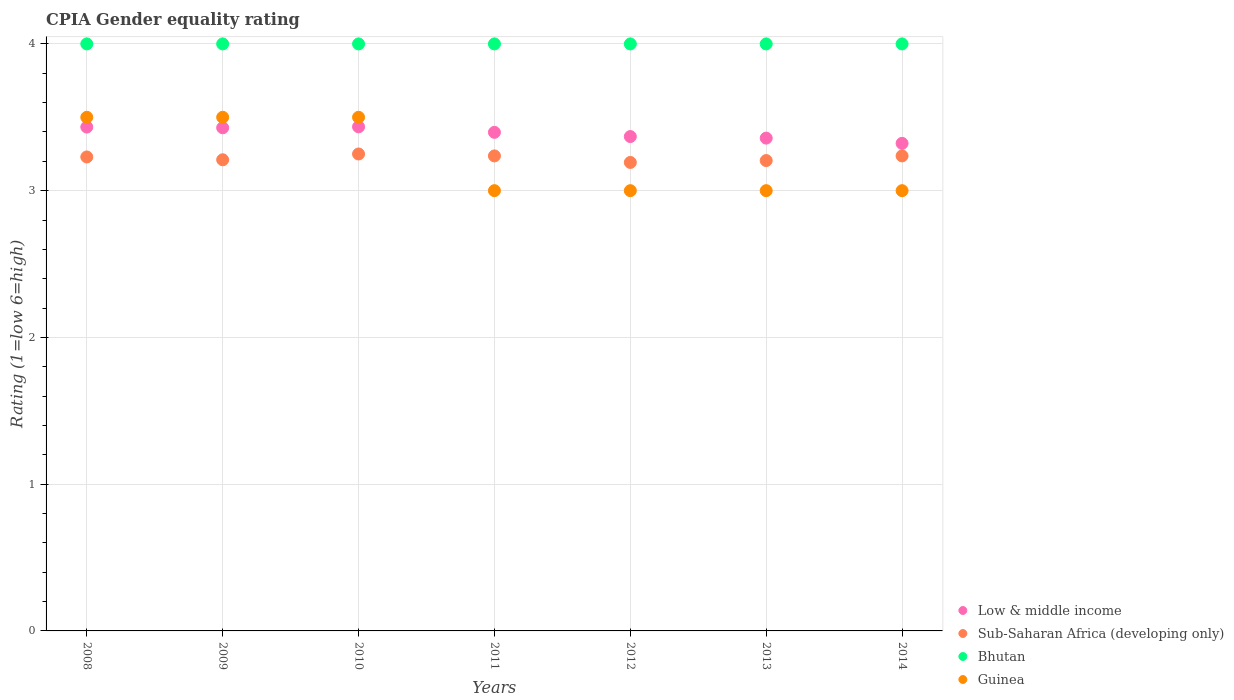Across all years, what is the maximum CPIA rating in Low & middle income?
Your answer should be very brief. 3.44. Across all years, what is the minimum CPIA rating in Guinea?
Offer a very short reply. 3. In which year was the CPIA rating in Guinea minimum?
Ensure brevity in your answer.  2011. What is the difference between the CPIA rating in Sub-Saharan Africa (developing only) in 2014 and the CPIA rating in Low & middle income in 2008?
Your response must be concise. -0.2. What is the average CPIA rating in Guinea per year?
Give a very brief answer. 3.21. In the year 2011, what is the difference between the CPIA rating in Bhutan and CPIA rating in Guinea?
Offer a terse response. 1. What is the ratio of the CPIA rating in Sub-Saharan Africa (developing only) in 2010 to that in 2013?
Keep it short and to the point. 1.01. Is the CPIA rating in Sub-Saharan Africa (developing only) in 2008 less than that in 2012?
Your answer should be compact. No. What is the difference between the highest and the second highest CPIA rating in Guinea?
Your answer should be compact. 0. What is the difference between the highest and the lowest CPIA rating in Sub-Saharan Africa (developing only)?
Provide a short and direct response. 0.06. In how many years, is the CPIA rating in Low & middle income greater than the average CPIA rating in Low & middle income taken over all years?
Provide a succinct answer. 4. Is the sum of the CPIA rating in Guinea in 2008 and 2010 greater than the maximum CPIA rating in Sub-Saharan Africa (developing only) across all years?
Keep it short and to the point. Yes. Is it the case that in every year, the sum of the CPIA rating in Guinea and CPIA rating in Low & middle income  is greater than the sum of CPIA rating in Sub-Saharan Africa (developing only) and CPIA rating in Bhutan?
Provide a succinct answer. No. Is the CPIA rating in Low & middle income strictly greater than the CPIA rating in Guinea over the years?
Your answer should be compact. No. Is the CPIA rating in Low & middle income strictly less than the CPIA rating in Sub-Saharan Africa (developing only) over the years?
Your response must be concise. No. How many dotlines are there?
Your answer should be very brief. 4. Does the graph contain any zero values?
Ensure brevity in your answer.  No. Does the graph contain grids?
Ensure brevity in your answer.  Yes. How are the legend labels stacked?
Offer a very short reply. Vertical. What is the title of the graph?
Offer a very short reply. CPIA Gender equality rating. What is the label or title of the X-axis?
Provide a succinct answer. Years. What is the Rating (1=low 6=high) in Low & middle income in 2008?
Give a very brief answer. 3.43. What is the Rating (1=low 6=high) of Sub-Saharan Africa (developing only) in 2008?
Give a very brief answer. 3.23. What is the Rating (1=low 6=high) in Bhutan in 2008?
Your response must be concise. 4. What is the Rating (1=low 6=high) of Guinea in 2008?
Offer a very short reply. 3.5. What is the Rating (1=low 6=high) of Low & middle income in 2009?
Provide a succinct answer. 3.43. What is the Rating (1=low 6=high) in Sub-Saharan Africa (developing only) in 2009?
Provide a short and direct response. 3.21. What is the Rating (1=low 6=high) of Bhutan in 2009?
Make the answer very short. 4. What is the Rating (1=low 6=high) of Guinea in 2009?
Ensure brevity in your answer.  3.5. What is the Rating (1=low 6=high) in Low & middle income in 2010?
Your answer should be very brief. 3.44. What is the Rating (1=low 6=high) of Sub-Saharan Africa (developing only) in 2010?
Offer a terse response. 3.25. What is the Rating (1=low 6=high) of Bhutan in 2010?
Offer a terse response. 4. What is the Rating (1=low 6=high) in Guinea in 2010?
Your answer should be compact. 3.5. What is the Rating (1=low 6=high) of Low & middle income in 2011?
Your answer should be compact. 3.4. What is the Rating (1=low 6=high) in Sub-Saharan Africa (developing only) in 2011?
Make the answer very short. 3.24. What is the Rating (1=low 6=high) in Bhutan in 2011?
Ensure brevity in your answer.  4. What is the Rating (1=low 6=high) of Guinea in 2011?
Offer a terse response. 3. What is the Rating (1=low 6=high) of Low & middle income in 2012?
Provide a short and direct response. 3.37. What is the Rating (1=low 6=high) in Sub-Saharan Africa (developing only) in 2012?
Keep it short and to the point. 3.19. What is the Rating (1=low 6=high) in Guinea in 2012?
Your answer should be very brief. 3. What is the Rating (1=low 6=high) in Low & middle income in 2013?
Ensure brevity in your answer.  3.36. What is the Rating (1=low 6=high) in Sub-Saharan Africa (developing only) in 2013?
Offer a very short reply. 3.21. What is the Rating (1=low 6=high) in Low & middle income in 2014?
Your answer should be compact. 3.32. What is the Rating (1=low 6=high) in Sub-Saharan Africa (developing only) in 2014?
Provide a succinct answer. 3.24. What is the Rating (1=low 6=high) in Guinea in 2014?
Ensure brevity in your answer.  3. Across all years, what is the maximum Rating (1=low 6=high) in Low & middle income?
Offer a very short reply. 3.44. Across all years, what is the maximum Rating (1=low 6=high) of Sub-Saharan Africa (developing only)?
Make the answer very short. 3.25. Across all years, what is the maximum Rating (1=low 6=high) in Guinea?
Provide a succinct answer. 3.5. Across all years, what is the minimum Rating (1=low 6=high) in Low & middle income?
Provide a succinct answer. 3.32. Across all years, what is the minimum Rating (1=low 6=high) of Sub-Saharan Africa (developing only)?
Give a very brief answer. 3.19. Across all years, what is the minimum Rating (1=low 6=high) in Bhutan?
Offer a very short reply. 4. Across all years, what is the minimum Rating (1=low 6=high) in Guinea?
Your response must be concise. 3. What is the total Rating (1=low 6=high) in Low & middle income in the graph?
Provide a short and direct response. 23.74. What is the total Rating (1=low 6=high) of Sub-Saharan Africa (developing only) in the graph?
Provide a succinct answer. 22.56. What is the total Rating (1=low 6=high) of Bhutan in the graph?
Your answer should be very brief. 28. What is the difference between the Rating (1=low 6=high) of Low & middle income in 2008 and that in 2009?
Keep it short and to the point. 0. What is the difference between the Rating (1=low 6=high) in Sub-Saharan Africa (developing only) in 2008 and that in 2009?
Make the answer very short. 0.02. What is the difference between the Rating (1=low 6=high) of Bhutan in 2008 and that in 2009?
Provide a short and direct response. 0. What is the difference between the Rating (1=low 6=high) in Low & middle income in 2008 and that in 2010?
Make the answer very short. -0. What is the difference between the Rating (1=low 6=high) in Sub-Saharan Africa (developing only) in 2008 and that in 2010?
Provide a short and direct response. -0.02. What is the difference between the Rating (1=low 6=high) of Low & middle income in 2008 and that in 2011?
Your response must be concise. 0.04. What is the difference between the Rating (1=low 6=high) of Sub-Saharan Africa (developing only) in 2008 and that in 2011?
Give a very brief answer. -0.01. What is the difference between the Rating (1=low 6=high) of Low & middle income in 2008 and that in 2012?
Ensure brevity in your answer.  0.06. What is the difference between the Rating (1=low 6=high) in Sub-Saharan Africa (developing only) in 2008 and that in 2012?
Your response must be concise. 0.04. What is the difference between the Rating (1=low 6=high) in Low & middle income in 2008 and that in 2013?
Make the answer very short. 0.08. What is the difference between the Rating (1=low 6=high) of Sub-Saharan Africa (developing only) in 2008 and that in 2013?
Your answer should be very brief. 0.02. What is the difference between the Rating (1=low 6=high) of Low & middle income in 2008 and that in 2014?
Keep it short and to the point. 0.11. What is the difference between the Rating (1=low 6=high) in Sub-Saharan Africa (developing only) in 2008 and that in 2014?
Provide a succinct answer. -0.01. What is the difference between the Rating (1=low 6=high) in Low & middle income in 2009 and that in 2010?
Your answer should be compact. -0.01. What is the difference between the Rating (1=low 6=high) of Sub-Saharan Africa (developing only) in 2009 and that in 2010?
Offer a very short reply. -0.04. What is the difference between the Rating (1=low 6=high) in Bhutan in 2009 and that in 2010?
Provide a succinct answer. 0. What is the difference between the Rating (1=low 6=high) in Guinea in 2009 and that in 2010?
Ensure brevity in your answer.  0. What is the difference between the Rating (1=low 6=high) in Low & middle income in 2009 and that in 2011?
Offer a very short reply. 0.03. What is the difference between the Rating (1=low 6=high) of Sub-Saharan Africa (developing only) in 2009 and that in 2011?
Keep it short and to the point. -0.03. What is the difference between the Rating (1=low 6=high) of Bhutan in 2009 and that in 2011?
Provide a succinct answer. 0. What is the difference between the Rating (1=low 6=high) in Guinea in 2009 and that in 2011?
Your response must be concise. 0.5. What is the difference between the Rating (1=low 6=high) of Low & middle income in 2009 and that in 2012?
Provide a short and direct response. 0.06. What is the difference between the Rating (1=low 6=high) of Sub-Saharan Africa (developing only) in 2009 and that in 2012?
Provide a succinct answer. 0.02. What is the difference between the Rating (1=low 6=high) in Guinea in 2009 and that in 2012?
Provide a succinct answer. 0.5. What is the difference between the Rating (1=low 6=high) in Low & middle income in 2009 and that in 2013?
Make the answer very short. 0.07. What is the difference between the Rating (1=low 6=high) in Sub-Saharan Africa (developing only) in 2009 and that in 2013?
Your answer should be compact. 0.01. What is the difference between the Rating (1=low 6=high) in Bhutan in 2009 and that in 2013?
Provide a succinct answer. 0. What is the difference between the Rating (1=low 6=high) of Guinea in 2009 and that in 2013?
Offer a terse response. 0.5. What is the difference between the Rating (1=low 6=high) of Low & middle income in 2009 and that in 2014?
Provide a succinct answer. 0.11. What is the difference between the Rating (1=low 6=high) in Sub-Saharan Africa (developing only) in 2009 and that in 2014?
Give a very brief answer. -0.03. What is the difference between the Rating (1=low 6=high) in Bhutan in 2009 and that in 2014?
Your response must be concise. 0. What is the difference between the Rating (1=low 6=high) in Low & middle income in 2010 and that in 2011?
Ensure brevity in your answer.  0.04. What is the difference between the Rating (1=low 6=high) of Sub-Saharan Africa (developing only) in 2010 and that in 2011?
Give a very brief answer. 0.01. What is the difference between the Rating (1=low 6=high) of Bhutan in 2010 and that in 2011?
Your answer should be very brief. 0. What is the difference between the Rating (1=low 6=high) of Guinea in 2010 and that in 2011?
Provide a succinct answer. 0.5. What is the difference between the Rating (1=low 6=high) of Low & middle income in 2010 and that in 2012?
Offer a terse response. 0.07. What is the difference between the Rating (1=low 6=high) in Sub-Saharan Africa (developing only) in 2010 and that in 2012?
Offer a terse response. 0.06. What is the difference between the Rating (1=low 6=high) of Low & middle income in 2010 and that in 2013?
Keep it short and to the point. 0.08. What is the difference between the Rating (1=low 6=high) in Sub-Saharan Africa (developing only) in 2010 and that in 2013?
Ensure brevity in your answer.  0.04. What is the difference between the Rating (1=low 6=high) of Low & middle income in 2010 and that in 2014?
Make the answer very short. 0.11. What is the difference between the Rating (1=low 6=high) in Sub-Saharan Africa (developing only) in 2010 and that in 2014?
Your answer should be compact. 0.01. What is the difference between the Rating (1=low 6=high) in Bhutan in 2010 and that in 2014?
Your response must be concise. 0. What is the difference between the Rating (1=low 6=high) in Guinea in 2010 and that in 2014?
Give a very brief answer. 0.5. What is the difference between the Rating (1=low 6=high) of Low & middle income in 2011 and that in 2012?
Provide a succinct answer. 0.03. What is the difference between the Rating (1=low 6=high) of Sub-Saharan Africa (developing only) in 2011 and that in 2012?
Your response must be concise. 0.04. What is the difference between the Rating (1=low 6=high) in Bhutan in 2011 and that in 2012?
Ensure brevity in your answer.  0. What is the difference between the Rating (1=low 6=high) of Guinea in 2011 and that in 2012?
Your answer should be very brief. 0. What is the difference between the Rating (1=low 6=high) in Low & middle income in 2011 and that in 2013?
Provide a short and direct response. 0.04. What is the difference between the Rating (1=low 6=high) in Sub-Saharan Africa (developing only) in 2011 and that in 2013?
Your response must be concise. 0.03. What is the difference between the Rating (1=low 6=high) of Low & middle income in 2011 and that in 2014?
Your response must be concise. 0.08. What is the difference between the Rating (1=low 6=high) of Guinea in 2011 and that in 2014?
Offer a very short reply. 0. What is the difference between the Rating (1=low 6=high) in Low & middle income in 2012 and that in 2013?
Offer a very short reply. 0.01. What is the difference between the Rating (1=low 6=high) of Sub-Saharan Africa (developing only) in 2012 and that in 2013?
Your answer should be very brief. -0.01. What is the difference between the Rating (1=low 6=high) of Bhutan in 2012 and that in 2013?
Offer a very short reply. 0. What is the difference between the Rating (1=low 6=high) of Low & middle income in 2012 and that in 2014?
Your response must be concise. 0.05. What is the difference between the Rating (1=low 6=high) in Sub-Saharan Africa (developing only) in 2012 and that in 2014?
Offer a terse response. -0.04. What is the difference between the Rating (1=low 6=high) of Guinea in 2012 and that in 2014?
Your answer should be very brief. 0. What is the difference between the Rating (1=low 6=high) of Low & middle income in 2013 and that in 2014?
Your response must be concise. 0.04. What is the difference between the Rating (1=low 6=high) of Sub-Saharan Africa (developing only) in 2013 and that in 2014?
Keep it short and to the point. -0.03. What is the difference between the Rating (1=low 6=high) of Guinea in 2013 and that in 2014?
Offer a terse response. 0. What is the difference between the Rating (1=low 6=high) in Low & middle income in 2008 and the Rating (1=low 6=high) in Sub-Saharan Africa (developing only) in 2009?
Give a very brief answer. 0.22. What is the difference between the Rating (1=low 6=high) of Low & middle income in 2008 and the Rating (1=low 6=high) of Bhutan in 2009?
Keep it short and to the point. -0.57. What is the difference between the Rating (1=low 6=high) of Low & middle income in 2008 and the Rating (1=low 6=high) of Guinea in 2009?
Give a very brief answer. -0.07. What is the difference between the Rating (1=low 6=high) of Sub-Saharan Africa (developing only) in 2008 and the Rating (1=low 6=high) of Bhutan in 2009?
Make the answer very short. -0.77. What is the difference between the Rating (1=low 6=high) in Sub-Saharan Africa (developing only) in 2008 and the Rating (1=low 6=high) in Guinea in 2009?
Provide a short and direct response. -0.27. What is the difference between the Rating (1=low 6=high) in Low & middle income in 2008 and the Rating (1=low 6=high) in Sub-Saharan Africa (developing only) in 2010?
Your answer should be very brief. 0.18. What is the difference between the Rating (1=low 6=high) in Low & middle income in 2008 and the Rating (1=low 6=high) in Bhutan in 2010?
Make the answer very short. -0.57. What is the difference between the Rating (1=low 6=high) of Low & middle income in 2008 and the Rating (1=low 6=high) of Guinea in 2010?
Your answer should be very brief. -0.07. What is the difference between the Rating (1=low 6=high) of Sub-Saharan Africa (developing only) in 2008 and the Rating (1=low 6=high) of Bhutan in 2010?
Your answer should be compact. -0.77. What is the difference between the Rating (1=low 6=high) of Sub-Saharan Africa (developing only) in 2008 and the Rating (1=low 6=high) of Guinea in 2010?
Make the answer very short. -0.27. What is the difference between the Rating (1=low 6=high) of Bhutan in 2008 and the Rating (1=low 6=high) of Guinea in 2010?
Ensure brevity in your answer.  0.5. What is the difference between the Rating (1=low 6=high) of Low & middle income in 2008 and the Rating (1=low 6=high) of Sub-Saharan Africa (developing only) in 2011?
Keep it short and to the point. 0.2. What is the difference between the Rating (1=low 6=high) of Low & middle income in 2008 and the Rating (1=low 6=high) of Bhutan in 2011?
Provide a short and direct response. -0.57. What is the difference between the Rating (1=low 6=high) of Low & middle income in 2008 and the Rating (1=low 6=high) of Guinea in 2011?
Your answer should be compact. 0.43. What is the difference between the Rating (1=low 6=high) in Sub-Saharan Africa (developing only) in 2008 and the Rating (1=low 6=high) in Bhutan in 2011?
Your response must be concise. -0.77. What is the difference between the Rating (1=low 6=high) in Sub-Saharan Africa (developing only) in 2008 and the Rating (1=low 6=high) in Guinea in 2011?
Provide a succinct answer. 0.23. What is the difference between the Rating (1=low 6=high) of Low & middle income in 2008 and the Rating (1=low 6=high) of Sub-Saharan Africa (developing only) in 2012?
Provide a short and direct response. 0.24. What is the difference between the Rating (1=low 6=high) of Low & middle income in 2008 and the Rating (1=low 6=high) of Bhutan in 2012?
Make the answer very short. -0.57. What is the difference between the Rating (1=low 6=high) of Low & middle income in 2008 and the Rating (1=low 6=high) of Guinea in 2012?
Your answer should be compact. 0.43. What is the difference between the Rating (1=low 6=high) in Sub-Saharan Africa (developing only) in 2008 and the Rating (1=low 6=high) in Bhutan in 2012?
Your answer should be very brief. -0.77. What is the difference between the Rating (1=low 6=high) in Sub-Saharan Africa (developing only) in 2008 and the Rating (1=low 6=high) in Guinea in 2012?
Your answer should be very brief. 0.23. What is the difference between the Rating (1=low 6=high) in Bhutan in 2008 and the Rating (1=low 6=high) in Guinea in 2012?
Your response must be concise. 1. What is the difference between the Rating (1=low 6=high) in Low & middle income in 2008 and the Rating (1=low 6=high) in Sub-Saharan Africa (developing only) in 2013?
Your answer should be very brief. 0.23. What is the difference between the Rating (1=low 6=high) of Low & middle income in 2008 and the Rating (1=low 6=high) of Bhutan in 2013?
Ensure brevity in your answer.  -0.57. What is the difference between the Rating (1=low 6=high) in Low & middle income in 2008 and the Rating (1=low 6=high) in Guinea in 2013?
Make the answer very short. 0.43. What is the difference between the Rating (1=low 6=high) in Sub-Saharan Africa (developing only) in 2008 and the Rating (1=low 6=high) in Bhutan in 2013?
Your answer should be very brief. -0.77. What is the difference between the Rating (1=low 6=high) of Sub-Saharan Africa (developing only) in 2008 and the Rating (1=low 6=high) of Guinea in 2013?
Provide a short and direct response. 0.23. What is the difference between the Rating (1=low 6=high) in Low & middle income in 2008 and the Rating (1=low 6=high) in Sub-Saharan Africa (developing only) in 2014?
Give a very brief answer. 0.2. What is the difference between the Rating (1=low 6=high) of Low & middle income in 2008 and the Rating (1=low 6=high) of Bhutan in 2014?
Offer a terse response. -0.57. What is the difference between the Rating (1=low 6=high) of Low & middle income in 2008 and the Rating (1=low 6=high) of Guinea in 2014?
Give a very brief answer. 0.43. What is the difference between the Rating (1=low 6=high) in Sub-Saharan Africa (developing only) in 2008 and the Rating (1=low 6=high) in Bhutan in 2014?
Ensure brevity in your answer.  -0.77. What is the difference between the Rating (1=low 6=high) in Sub-Saharan Africa (developing only) in 2008 and the Rating (1=low 6=high) in Guinea in 2014?
Ensure brevity in your answer.  0.23. What is the difference between the Rating (1=low 6=high) in Low & middle income in 2009 and the Rating (1=low 6=high) in Sub-Saharan Africa (developing only) in 2010?
Provide a succinct answer. 0.18. What is the difference between the Rating (1=low 6=high) of Low & middle income in 2009 and the Rating (1=low 6=high) of Bhutan in 2010?
Your response must be concise. -0.57. What is the difference between the Rating (1=low 6=high) in Low & middle income in 2009 and the Rating (1=low 6=high) in Guinea in 2010?
Ensure brevity in your answer.  -0.07. What is the difference between the Rating (1=low 6=high) in Sub-Saharan Africa (developing only) in 2009 and the Rating (1=low 6=high) in Bhutan in 2010?
Give a very brief answer. -0.79. What is the difference between the Rating (1=low 6=high) of Sub-Saharan Africa (developing only) in 2009 and the Rating (1=low 6=high) of Guinea in 2010?
Provide a short and direct response. -0.29. What is the difference between the Rating (1=low 6=high) of Low & middle income in 2009 and the Rating (1=low 6=high) of Sub-Saharan Africa (developing only) in 2011?
Your answer should be very brief. 0.19. What is the difference between the Rating (1=low 6=high) in Low & middle income in 2009 and the Rating (1=low 6=high) in Bhutan in 2011?
Give a very brief answer. -0.57. What is the difference between the Rating (1=low 6=high) in Low & middle income in 2009 and the Rating (1=low 6=high) in Guinea in 2011?
Offer a very short reply. 0.43. What is the difference between the Rating (1=low 6=high) in Sub-Saharan Africa (developing only) in 2009 and the Rating (1=low 6=high) in Bhutan in 2011?
Keep it short and to the point. -0.79. What is the difference between the Rating (1=low 6=high) of Sub-Saharan Africa (developing only) in 2009 and the Rating (1=low 6=high) of Guinea in 2011?
Offer a very short reply. 0.21. What is the difference between the Rating (1=low 6=high) in Low & middle income in 2009 and the Rating (1=low 6=high) in Sub-Saharan Africa (developing only) in 2012?
Provide a succinct answer. 0.24. What is the difference between the Rating (1=low 6=high) of Low & middle income in 2009 and the Rating (1=low 6=high) of Bhutan in 2012?
Make the answer very short. -0.57. What is the difference between the Rating (1=low 6=high) of Low & middle income in 2009 and the Rating (1=low 6=high) of Guinea in 2012?
Offer a terse response. 0.43. What is the difference between the Rating (1=low 6=high) in Sub-Saharan Africa (developing only) in 2009 and the Rating (1=low 6=high) in Bhutan in 2012?
Offer a very short reply. -0.79. What is the difference between the Rating (1=low 6=high) of Sub-Saharan Africa (developing only) in 2009 and the Rating (1=low 6=high) of Guinea in 2012?
Ensure brevity in your answer.  0.21. What is the difference between the Rating (1=low 6=high) of Bhutan in 2009 and the Rating (1=low 6=high) of Guinea in 2012?
Offer a very short reply. 1. What is the difference between the Rating (1=low 6=high) in Low & middle income in 2009 and the Rating (1=low 6=high) in Sub-Saharan Africa (developing only) in 2013?
Keep it short and to the point. 0.22. What is the difference between the Rating (1=low 6=high) of Low & middle income in 2009 and the Rating (1=low 6=high) of Bhutan in 2013?
Provide a succinct answer. -0.57. What is the difference between the Rating (1=low 6=high) in Low & middle income in 2009 and the Rating (1=low 6=high) in Guinea in 2013?
Offer a terse response. 0.43. What is the difference between the Rating (1=low 6=high) of Sub-Saharan Africa (developing only) in 2009 and the Rating (1=low 6=high) of Bhutan in 2013?
Make the answer very short. -0.79. What is the difference between the Rating (1=low 6=high) in Sub-Saharan Africa (developing only) in 2009 and the Rating (1=low 6=high) in Guinea in 2013?
Your answer should be compact. 0.21. What is the difference between the Rating (1=low 6=high) of Low & middle income in 2009 and the Rating (1=low 6=high) of Sub-Saharan Africa (developing only) in 2014?
Keep it short and to the point. 0.19. What is the difference between the Rating (1=low 6=high) in Low & middle income in 2009 and the Rating (1=low 6=high) in Bhutan in 2014?
Ensure brevity in your answer.  -0.57. What is the difference between the Rating (1=low 6=high) in Low & middle income in 2009 and the Rating (1=low 6=high) in Guinea in 2014?
Your answer should be compact. 0.43. What is the difference between the Rating (1=low 6=high) of Sub-Saharan Africa (developing only) in 2009 and the Rating (1=low 6=high) of Bhutan in 2014?
Your answer should be compact. -0.79. What is the difference between the Rating (1=low 6=high) of Sub-Saharan Africa (developing only) in 2009 and the Rating (1=low 6=high) of Guinea in 2014?
Offer a very short reply. 0.21. What is the difference between the Rating (1=low 6=high) in Low & middle income in 2010 and the Rating (1=low 6=high) in Sub-Saharan Africa (developing only) in 2011?
Ensure brevity in your answer.  0.2. What is the difference between the Rating (1=low 6=high) of Low & middle income in 2010 and the Rating (1=low 6=high) of Bhutan in 2011?
Offer a terse response. -0.56. What is the difference between the Rating (1=low 6=high) in Low & middle income in 2010 and the Rating (1=low 6=high) in Guinea in 2011?
Your answer should be compact. 0.44. What is the difference between the Rating (1=low 6=high) of Sub-Saharan Africa (developing only) in 2010 and the Rating (1=low 6=high) of Bhutan in 2011?
Offer a terse response. -0.75. What is the difference between the Rating (1=low 6=high) in Bhutan in 2010 and the Rating (1=low 6=high) in Guinea in 2011?
Offer a terse response. 1. What is the difference between the Rating (1=low 6=high) in Low & middle income in 2010 and the Rating (1=low 6=high) in Sub-Saharan Africa (developing only) in 2012?
Provide a succinct answer. 0.24. What is the difference between the Rating (1=low 6=high) in Low & middle income in 2010 and the Rating (1=low 6=high) in Bhutan in 2012?
Your response must be concise. -0.56. What is the difference between the Rating (1=low 6=high) of Low & middle income in 2010 and the Rating (1=low 6=high) of Guinea in 2012?
Give a very brief answer. 0.44. What is the difference between the Rating (1=low 6=high) in Sub-Saharan Africa (developing only) in 2010 and the Rating (1=low 6=high) in Bhutan in 2012?
Your answer should be very brief. -0.75. What is the difference between the Rating (1=low 6=high) of Sub-Saharan Africa (developing only) in 2010 and the Rating (1=low 6=high) of Guinea in 2012?
Provide a succinct answer. 0.25. What is the difference between the Rating (1=low 6=high) in Bhutan in 2010 and the Rating (1=low 6=high) in Guinea in 2012?
Your response must be concise. 1. What is the difference between the Rating (1=low 6=high) in Low & middle income in 2010 and the Rating (1=low 6=high) in Sub-Saharan Africa (developing only) in 2013?
Provide a short and direct response. 0.23. What is the difference between the Rating (1=low 6=high) in Low & middle income in 2010 and the Rating (1=low 6=high) in Bhutan in 2013?
Offer a terse response. -0.56. What is the difference between the Rating (1=low 6=high) of Low & middle income in 2010 and the Rating (1=low 6=high) of Guinea in 2013?
Provide a short and direct response. 0.44. What is the difference between the Rating (1=low 6=high) in Sub-Saharan Africa (developing only) in 2010 and the Rating (1=low 6=high) in Bhutan in 2013?
Give a very brief answer. -0.75. What is the difference between the Rating (1=low 6=high) in Bhutan in 2010 and the Rating (1=low 6=high) in Guinea in 2013?
Give a very brief answer. 1. What is the difference between the Rating (1=low 6=high) in Low & middle income in 2010 and the Rating (1=low 6=high) in Sub-Saharan Africa (developing only) in 2014?
Your answer should be compact. 0.2. What is the difference between the Rating (1=low 6=high) of Low & middle income in 2010 and the Rating (1=low 6=high) of Bhutan in 2014?
Keep it short and to the point. -0.56. What is the difference between the Rating (1=low 6=high) of Low & middle income in 2010 and the Rating (1=low 6=high) of Guinea in 2014?
Your answer should be very brief. 0.44. What is the difference between the Rating (1=low 6=high) in Sub-Saharan Africa (developing only) in 2010 and the Rating (1=low 6=high) in Bhutan in 2014?
Give a very brief answer. -0.75. What is the difference between the Rating (1=low 6=high) of Bhutan in 2010 and the Rating (1=low 6=high) of Guinea in 2014?
Your answer should be very brief. 1. What is the difference between the Rating (1=low 6=high) of Low & middle income in 2011 and the Rating (1=low 6=high) of Sub-Saharan Africa (developing only) in 2012?
Offer a very short reply. 0.21. What is the difference between the Rating (1=low 6=high) of Low & middle income in 2011 and the Rating (1=low 6=high) of Bhutan in 2012?
Your answer should be compact. -0.6. What is the difference between the Rating (1=low 6=high) of Low & middle income in 2011 and the Rating (1=low 6=high) of Guinea in 2012?
Your answer should be compact. 0.4. What is the difference between the Rating (1=low 6=high) in Sub-Saharan Africa (developing only) in 2011 and the Rating (1=low 6=high) in Bhutan in 2012?
Make the answer very short. -0.76. What is the difference between the Rating (1=low 6=high) of Sub-Saharan Africa (developing only) in 2011 and the Rating (1=low 6=high) of Guinea in 2012?
Your answer should be compact. 0.24. What is the difference between the Rating (1=low 6=high) in Bhutan in 2011 and the Rating (1=low 6=high) in Guinea in 2012?
Give a very brief answer. 1. What is the difference between the Rating (1=low 6=high) of Low & middle income in 2011 and the Rating (1=low 6=high) of Sub-Saharan Africa (developing only) in 2013?
Your answer should be compact. 0.19. What is the difference between the Rating (1=low 6=high) in Low & middle income in 2011 and the Rating (1=low 6=high) in Bhutan in 2013?
Give a very brief answer. -0.6. What is the difference between the Rating (1=low 6=high) in Low & middle income in 2011 and the Rating (1=low 6=high) in Guinea in 2013?
Your answer should be very brief. 0.4. What is the difference between the Rating (1=low 6=high) of Sub-Saharan Africa (developing only) in 2011 and the Rating (1=low 6=high) of Bhutan in 2013?
Provide a succinct answer. -0.76. What is the difference between the Rating (1=low 6=high) of Sub-Saharan Africa (developing only) in 2011 and the Rating (1=low 6=high) of Guinea in 2013?
Ensure brevity in your answer.  0.24. What is the difference between the Rating (1=low 6=high) in Low & middle income in 2011 and the Rating (1=low 6=high) in Sub-Saharan Africa (developing only) in 2014?
Your answer should be compact. 0.16. What is the difference between the Rating (1=low 6=high) of Low & middle income in 2011 and the Rating (1=low 6=high) of Bhutan in 2014?
Offer a very short reply. -0.6. What is the difference between the Rating (1=low 6=high) in Low & middle income in 2011 and the Rating (1=low 6=high) in Guinea in 2014?
Ensure brevity in your answer.  0.4. What is the difference between the Rating (1=low 6=high) of Sub-Saharan Africa (developing only) in 2011 and the Rating (1=low 6=high) of Bhutan in 2014?
Make the answer very short. -0.76. What is the difference between the Rating (1=low 6=high) in Sub-Saharan Africa (developing only) in 2011 and the Rating (1=low 6=high) in Guinea in 2014?
Offer a very short reply. 0.24. What is the difference between the Rating (1=low 6=high) of Bhutan in 2011 and the Rating (1=low 6=high) of Guinea in 2014?
Provide a succinct answer. 1. What is the difference between the Rating (1=low 6=high) in Low & middle income in 2012 and the Rating (1=low 6=high) in Sub-Saharan Africa (developing only) in 2013?
Your answer should be very brief. 0.16. What is the difference between the Rating (1=low 6=high) of Low & middle income in 2012 and the Rating (1=low 6=high) of Bhutan in 2013?
Ensure brevity in your answer.  -0.63. What is the difference between the Rating (1=low 6=high) of Low & middle income in 2012 and the Rating (1=low 6=high) of Guinea in 2013?
Offer a very short reply. 0.37. What is the difference between the Rating (1=low 6=high) of Sub-Saharan Africa (developing only) in 2012 and the Rating (1=low 6=high) of Bhutan in 2013?
Ensure brevity in your answer.  -0.81. What is the difference between the Rating (1=low 6=high) of Sub-Saharan Africa (developing only) in 2012 and the Rating (1=low 6=high) of Guinea in 2013?
Ensure brevity in your answer.  0.19. What is the difference between the Rating (1=low 6=high) in Bhutan in 2012 and the Rating (1=low 6=high) in Guinea in 2013?
Your answer should be very brief. 1. What is the difference between the Rating (1=low 6=high) in Low & middle income in 2012 and the Rating (1=low 6=high) in Sub-Saharan Africa (developing only) in 2014?
Keep it short and to the point. 0.13. What is the difference between the Rating (1=low 6=high) in Low & middle income in 2012 and the Rating (1=low 6=high) in Bhutan in 2014?
Provide a succinct answer. -0.63. What is the difference between the Rating (1=low 6=high) in Low & middle income in 2012 and the Rating (1=low 6=high) in Guinea in 2014?
Provide a short and direct response. 0.37. What is the difference between the Rating (1=low 6=high) of Sub-Saharan Africa (developing only) in 2012 and the Rating (1=low 6=high) of Bhutan in 2014?
Give a very brief answer. -0.81. What is the difference between the Rating (1=low 6=high) of Sub-Saharan Africa (developing only) in 2012 and the Rating (1=low 6=high) of Guinea in 2014?
Keep it short and to the point. 0.19. What is the difference between the Rating (1=low 6=high) in Bhutan in 2012 and the Rating (1=low 6=high) in Guinea in 2014?
Ensure brevity in your answer.  1. What is the difference between the Rating (1=low 6=high) in Low & middle income in 2013 and the Rating (1=low 6=high) in Sub-Saharan Africa (developing only) in 2014?
Ensure brevity in your answer.  0.12. What is the difference between the Rating (1=low 6=high) in Low & middle income in 2013 and the Rating (1=low 6=high) in Bhutan in 2014?
Your answer should be compact. -0.64. What is the difference between the Rating (1=low 6=high) of Low & middle income in 2013 and the Rating (1=low 6=high) of Guinea in 2014?
Make the answer very short. 0.36. What is the difference between the Rating (1=low 6=high) of Sub-Saharan Africa (developing only) in 2013 and the Rating (1=low 6=high) of Bhutan in 2014?
Provide a succinct answer. -0.79. What is the difference between the Rating (1=low 6=high) in Sub-Saharan Africa (developing only) in 2013 and the Rating (1=low 6=high) in Guinea in 2014?
Your answer should be compact. 0.21. What is the difference between the Rating (1=low 6=high) in Bhutan in 2013 and the Rating (1=low 6=high) in Guinea in 2014?
Ensure brevity in your answer.  1. What is the average Rating (1=low 6=high) of Low & middle income per year?
Your answer should be very brief. 3.39. What is the average Rating (1=low 6=high) in Sub-Saharan Africa (developing only) per year?
Offer a terse response. 3.22. What is the average Rating (1=low 6=high) in Guinea per year?
Ensure brevity in your answer.  3.21. In the year 2008, what is the difference between the Rating (1=low 6=high) of Low & middle income and Rating (1=low 6=high) of Sub-Saharan Africa (developing only)?
Provide a short and direct response. 0.2. In the year 2008, what is the difference between the Rating (1=low 6=high) of Low & middle income and Rating (1=low 6=high) of Bhutan?
Provide a succinct answer. -0.57. In the year 2008, what is the difference between the Rating (1=low 6=high) of Low & middle income and Rating (1=low 6=high) of Guinea?
Provide a succinct answer. -0.07. In the year 2008, what is the difference between the Rating (1=low 6=high) of Sub-Saharan Africa (developing only) and Rating (1=low 6=high) of Bhutan?
Your answer should be very brief. -0.77. In the year 2008, what is the difference between the Rating (1=low 6=high) in Sub-Saharan Africa (developing only) and Rating (1=low 6=high) in Guinea?
Your response must be concise. -0.27. In the year 2009, what is the difference between the Rating (1=low 6=high) of Low & middle income and Rating (1=low 6=high) of Sub-Saharan Africa (developing only)?
Provide a short and direct response. 0.22. In the year 2009, what is the difference between the Rating (1=low 6=high) in Low & middle income and Rating (1=low 6=high) in Bhutan?
Provide a succinct answer. -0.57. In the year 2009, what is the difference between the Rating (1=low 6=high) in Low & middle income and Rating (1=low 6=high) in Guinea?
Provide a succinct answer. -0.07. In the year 2009, what is the difference between the Rating (1=low 6=high) of Sub-Saharan Africa (developing only) and Rating (1=low 6=high) of Bhutan?
Your response must be concise. -0.79. In the year 2009, what is the difference between the Rating (1=low 6=high) of Sub-Saharan Africa (developing only) and Rating (1=low 6=high) of Guinea?
Provide a succinct answer. -0.29. In the year 2010, what is the difference between the Rating (1=low 6=high) of Low & middle income and Rating (1=low 6=high) of Sub-Saharan Africa (developing only)?
Keep it short and to the point. 0.19. In the year 2010, what is the difference between the Rating (1=low 6=high) of Low & middle income and Rating (1=low 6=high) of Bhutan?
Provide a succinct answer. -0.56. In the year 2010, what is the difference between the Rating (1=low 6=high) in Low & middle income and Rating (1=low 6=high) in Guinea?
Your answer should be very brief. -0.06. In the year 2010, what is the difference between the Rating (1=low 6=high) of Sub-Saharan Africa (developing only) and Rating (1=low 6=high) of Bhutan?
Keep it short and to the point. -0.75. In the year 2011, what is the difference between the Rating (1=low 6=high) in Low & middle income and Rating (1=low 6=high) in Sub-Saharan Africa (developing only)?
Provide a succinct answer. 0.16. In the year 2011, what is the difference between the Rating (1=low 6=high) of Low & middle income and Rating (1=low 6=high) of Bhutan?
Your response must be concise. -0.6. In the year 2011, what is the difference between the Rating (1=low 6=high) in Low & middle income and Rating (1=low 6=high) in Guinea?
Keep it short and to the point. 0.4. In the year 2011, what is the difference between the Rating (1=low 6=high) in Sub-Saharan Africa (developing only) and Rating (1=low 6=high) in Bhutan?
Make the answer very short. -0.76. In the year 2011, what is the difference between the Rating (1=low 6=high) of Sub-Saharan Africa (developing only) and Rating (1=low 6=high) of Guinea?
Make the answer very short. 0.24. In the year 2012, what is the difference between the Rating (1=low 6=high) in Low & middle income and Rating (1=low 6=high) in Sub-Saharan Africa (developing only)?
Your answer should be compact. 0.18. In the year 2012, what is the difference between the Rating (1=low 6=high) of Low & middle income and Rating (1=low 6=high) of Bhutan?
Your answer should be very brief. -0.63. In the year 2012, what is the difference between the Rating (1=low 6=high) of Low & middle income and Rating (1=low 6=high) of Guinea?
Give a very brief answer. 0.37. In the year 2012, what is the difference between the Rating (1=low 6=high) in Sub-Saharan Africa (developing only) and Rating (1=low 6=high) in Bhutan?
Make the answer very short. -0.81. In the year 2012, what is the difference between the Rating (1=low 6=high) in Sub-Saharan Africa (developing only) and Rating (1=low 6=high) in Guinea?
Your answer should be compact. 0.19. In the year 2012, what is the difference between the Rating (1=low 6=high) in Bhutan and Rating (1=low 6=high) in Guinea?
Make the answer very short. 1. In the year 2013, what is the difference between the Rating (1=low 6=high) in Low & middle income and Rating (1=low 6=high) in Sub-Saharan Africa (developing only)?
Your answer should be compact. 0.15. In the year 2013, what is the difference between the Rating (1=low 6=high) of Low & middle income and Rating (1=low 6=high) of Bhutan?
Your answer should be very brief. -0.64. In the year 2013, what is the difference between the Rating (1=low 6=high) of Low & middle income and Rating (1=low 6=high) of Guinea?
Your response must be concise. 0.36. In the year 2013, what is the difference between the Rating (1=low 6=high) in Sub-Saharan Africa (developing only) and Rating (1=low 6=high) in Bhutan?
Provide a succinct answer. -0.79. In the year 2013, what is the difference between the Rating (1=low 6=high) of Sub-Saharan Africa (developing only) and Rating (1=low 6=high) of Guinea?
Your response must be concise. 0.21. In the year 2014, what is the difference between the Rating (1=low 6=high) of Low & middle income and Rating (1=low 6=high) of Sub-Saharan Africa (developing only)?
Your answer should be very brief. 0.09. In the year 2014, what is the difference between the Rating (1=low 6=high) in Low & middle income and Rating (1=low 6=high) in Bhutan?
Your answer should be compact. -0.68. In the year 2014, what is the difference between the Rating (1=low 6=high) of Low & middle income and Rating (1=low 6=high) of Guinea?
Ensure brevity in your answer.  0.32. In the year 2014, what is the difference between the Rating (1=low 6=high) in Sub-Saharan Africa (developing only) and Rating (1=low 6=high) in Bhutan?
Your response must be concise. -0.76. In the year 2014, what is the difference between the Rating (1=low 6=high) in Sub-Saharan Africa (developing only) and Rating (1=low 6=high) in Guinea?
Your answer should be compact. 0.24. In the year 2014, what is the difference between the Rating (1=low 6=high) of Bhutan and Rating (1=low 6=high) of Guinea?
Offer a very short reply. 1. What is the ratio of the Rating (1=low 6=high) in Bhutan in 2008 to that in 2009?
Provide a succinct answer. 1. What is the ratio of the Rating (1=low 6=high) in Bhutan in 2008 to that in 2010?
Make the answer very short. 1. What is the ratio of the Rating (1=low 6=high) of Low & middle income in 2008 to that in 2011?
Ensure brevity in your answer.  1.01. What is the ratio of the Rating (1=low 6=high) of Low & middle income in 2008 to that in 2012?
Provide a short and direct response. 1.02. What is the ratio of the Rating (1=low 6=high) of Sub-Saharan Africa (developing only) in 2008 to that in 2012?
Your response must be concise. 1.01. What is the ratio of the Rating (1=low 6=high) in Bhutan in 2008 to that in 2012?
Provide a short and direct response. 1. What is the ratio of the Rating (1=low 6=high) of Guinea in 2008 to that in 2012?
Offer a very short reply. 1.17. What is the ratio of the Rating (1=low 6=high) of Low & middle income in 2008 to that in 2013?
Offer a terse response. 1.02. What is the ratio of the Rating (1=low 6=high) in Sub-Saharan Africa (developing only) in 2008 to that in 2013?
Give a very brief answer. 1.01. What is the ratio of the Rating (1=low 6=high) of Bhutan in 2008 to that in 2013?
Offer a very short reply. 1. What is the ratio of the Rating (1=low 6=high) of Guinea in 2008 to that in 2013?
Provide a short and direct response. 1.17. What is the ratio of the Rating (1=low 6=high) of Low & middle income in 2008 to that in 2014?
Your answer should be very brief. 1.03. What is the ratio of the Rating (1=low 6=high) in Low & middle income in 2009 to that in 2010?
Provide a short and direct response. 1. What is the ratio of the Rating (1=low 6=high) of Sub-Saharan Africa (developing only) in 2009 to that in 2010?
Make the answer very short. 0.99. What is the ratio of the Rating (1=low 6=high) of Bhutan in 2009 to that in 2010?
Your answer should be compact. 1. What is the ratio of the Rating (1=low 6=high) in Low & middle income in 2009 to that in 2011?
Offer a very short reply. 1.01. What is the ratio of the Rating (1=low 6=high) of Sub-Saharan Africa (developing only) in 2009 to that in 2011?
Ensure brevity in your answer.  0.99. What is the ratio of the Rating (1=low 6=high) of Bhutan in 2009 to that in 2011?
Provide a short and direct response. 1. What is the ratio of the Rating (1=low 6=high) in Low & middle income in 2009 to that in 2012?
Your answer should be very brief. 1.02. What is the ratio of the Rating (1=low 6=high) in Bhutan in 2009 to that in 2012?
Provide a succinct answer. 1. What is the ratio of the Rating (1=low 6=high) of Low & middle income in 2009 to that in 2013?
Your answer should be compact. 1.02. What is the ratio of the Rating (1=low 6=high) of Sub-Saharan Africa (developing only) in 2009 to that in 2013?
Offer a very short reply. 1. What is the ratio of the Rating (1=low 6=high) of Guinea in 2009 to that in 2013?
Offer a very short reply. 1.17. What is the ratio of the Rating (1=low 6=high) of Low & middle income in 2009 to that in 2014?
Make the answer very short. 1.03. What is the ratio of the Rating (1=low 6=high) of Bhutan in 2009 to that in 2014?
Make the answer very short. 1. What is the ratio of the Rating (1=low 6=high) of Low & middle income in 2010 to that in 2011?
Your response must be concise. 1.01. What is the ratio of the Rating (1=low 6=high) of Bhutan in 2010 to that in 2011?
Your response must be concise. 1. What is the ratio of the Rating (1=low 6=high) of Guinea in 2010 to that in 2011?
Your answer should be compact. 1.17. What is the ratio of the Rating (1=low 6=high) of Low & middle income in 2010 to that in 2012?
Offer a terse response. 1.02. What is the ratio of the Rating (1=low 6=high) in Sub-Saharan Africa (developing only) in 2010 to that in 2012?
Give a very brief answer. 1.02. What is the ratio of the Rating (1=low 6=high) in Bhutan in 2010 to that in 2012?
Offer a very short reply. 1. What is the ratio of the Rating (1=low 6=high) of Guinea in 2010 to that in 2012?
Your response must be concise. 1.17. What is the ratio of the Rating (1=low 6=high) in Low & middle income in 2010 to that in 2013?
Keep it short and to the point. 1.02. What is the ratio of the Rating (1=low 6=high) of Sub-Saharan Africa (developing only) in 2010 to that in 2013?
Ensure brevity in your answer.  1.01. What is the ratio of the Rating (1=low 6=high) in Bhutan in 2010 to that in 2013?
Your response must be concise. 1. What is the ratio of the Rating (1=low 6=high) of Low & middle income in 2010 to that in 2014?
Give a very brief answer. 1.03. What is the ratio of the Rating (1=low 6=high) in Low & middle income in 2011 to that in 2012?
Keep it short and to the point. 1.01. What is the ratio of the Rating (1=low 6=high) of Low & middle income in 2011 to that in 2013?
Give a very brief answer. 1.01. What is the ratio of the Rating (1=low 6=high) of Sub-Saharan Africa (developing only) in 2011 to that in 2013?
Offer a very short reply. 1.01. What is the ratio of the Rating (1=low 6=high) of Bhutan in 2011 to that in 2013?
Keep it short and to the point. 1. What is the ratio of the Rating (1=low 6=high) in Low & middle income in 2011 to that in 2014?
Offer a terse response. 1.02. What is the ratio of the Rating (1=low 6=high) in Sub-Saharan Africa (developing only) in 2012 to that in 2013?
Your response must be concise. 1. What is the ratio of the Rating (1=low 6=high) of Guinea in 2012 to that in 2013?
Ensure brevity in your answer.  1. What is the ratio of the Rating (1=low 6=high) of Sub-Saharan Africa (developing only) in 2012 to that in 2014?
Provide a short and direct response. 0.99. What is the ratio of the Rating (1=low 6=high) of Guinea in 2012 to that in 2014?
Give a very brief answer. 1. What is the ratio of the Rating (1=low 6=high) in Low & middle income in 2013 to that in 2014?
Offer a very short reply. 1.01. What is the ratio of the Rating (1=low 6=high) in Sub-Saharan Africa (developing only) in 2013 to that in 2014?
Give a very brief answer. 0.99. What is the ratio of the Rating (1=low 6=high) in Bhutan in 2013 to that in 2014?
Provide a short and direct response. 1. What is the ratio of the Rating (1=low 6=high) of Guinea in 2013 to that in 2014?
Provide a succinct answer. 1. What is the difference between the highest and the second highest Rating (1=low 6=high) of Low & middle income?
Your answer should be very brief. 0. What is the difference between the highest and the second highest Rating (1=low 6=high) of Sub-Saharan Africa (developing only)?
Offer a very short reply. 0.01. What is the difference between the highest and the lowest Rating (1=low 6=high) in Low & middle income?
Keep it short and to the point. 0.11. What is the difference between the highest and the lowest Rating (1=low 6=high) in Sub-Saharan Africa (developing only)?
Your answer should be very brief. 0.06. 